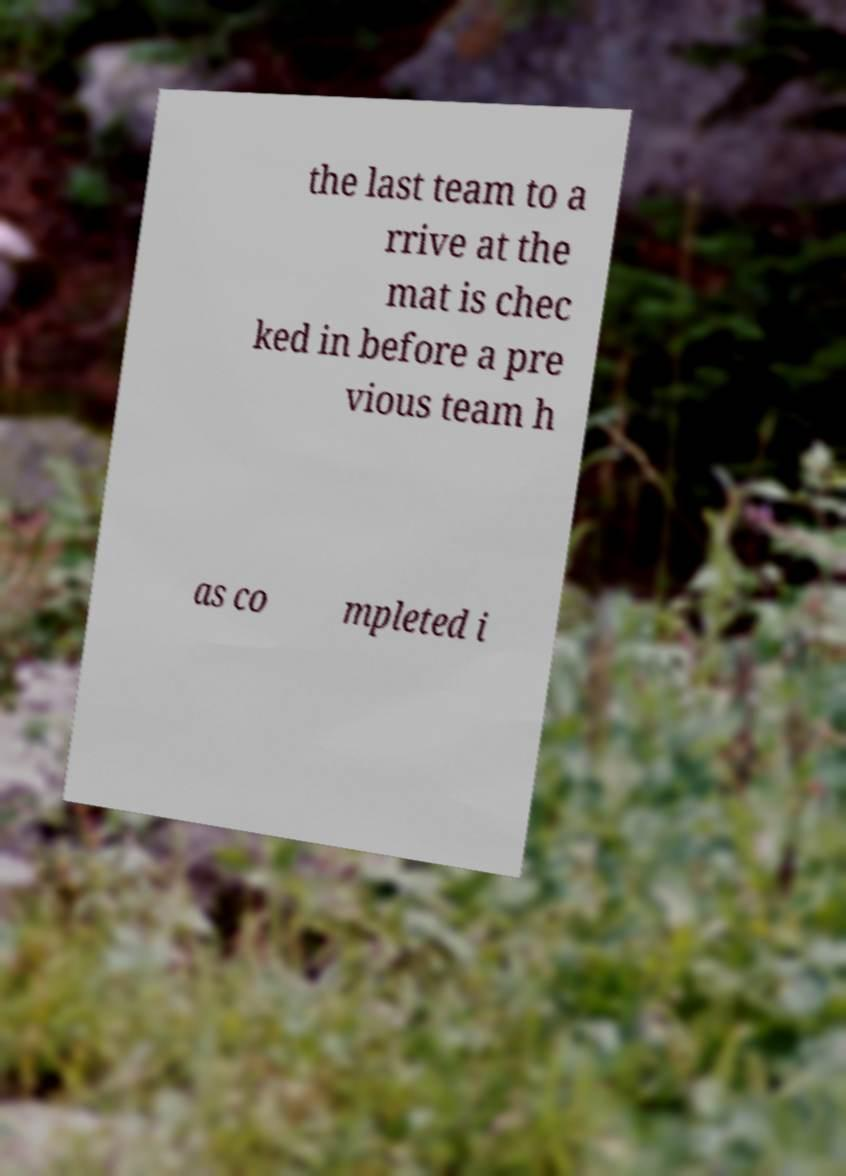What messages or text are displayed in this image? I need them in a readable, typed format. the last team to a rrive at the mat is chec ked in before a pre vious team h as co mpleted i 